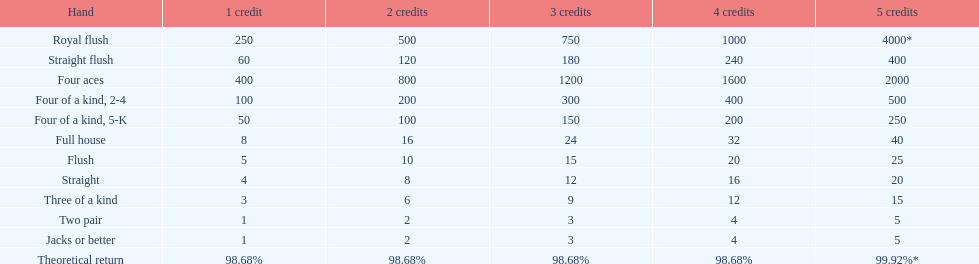Can a 2-credit full house be compared to a 5-credit three of a kind in terms of value? No. 